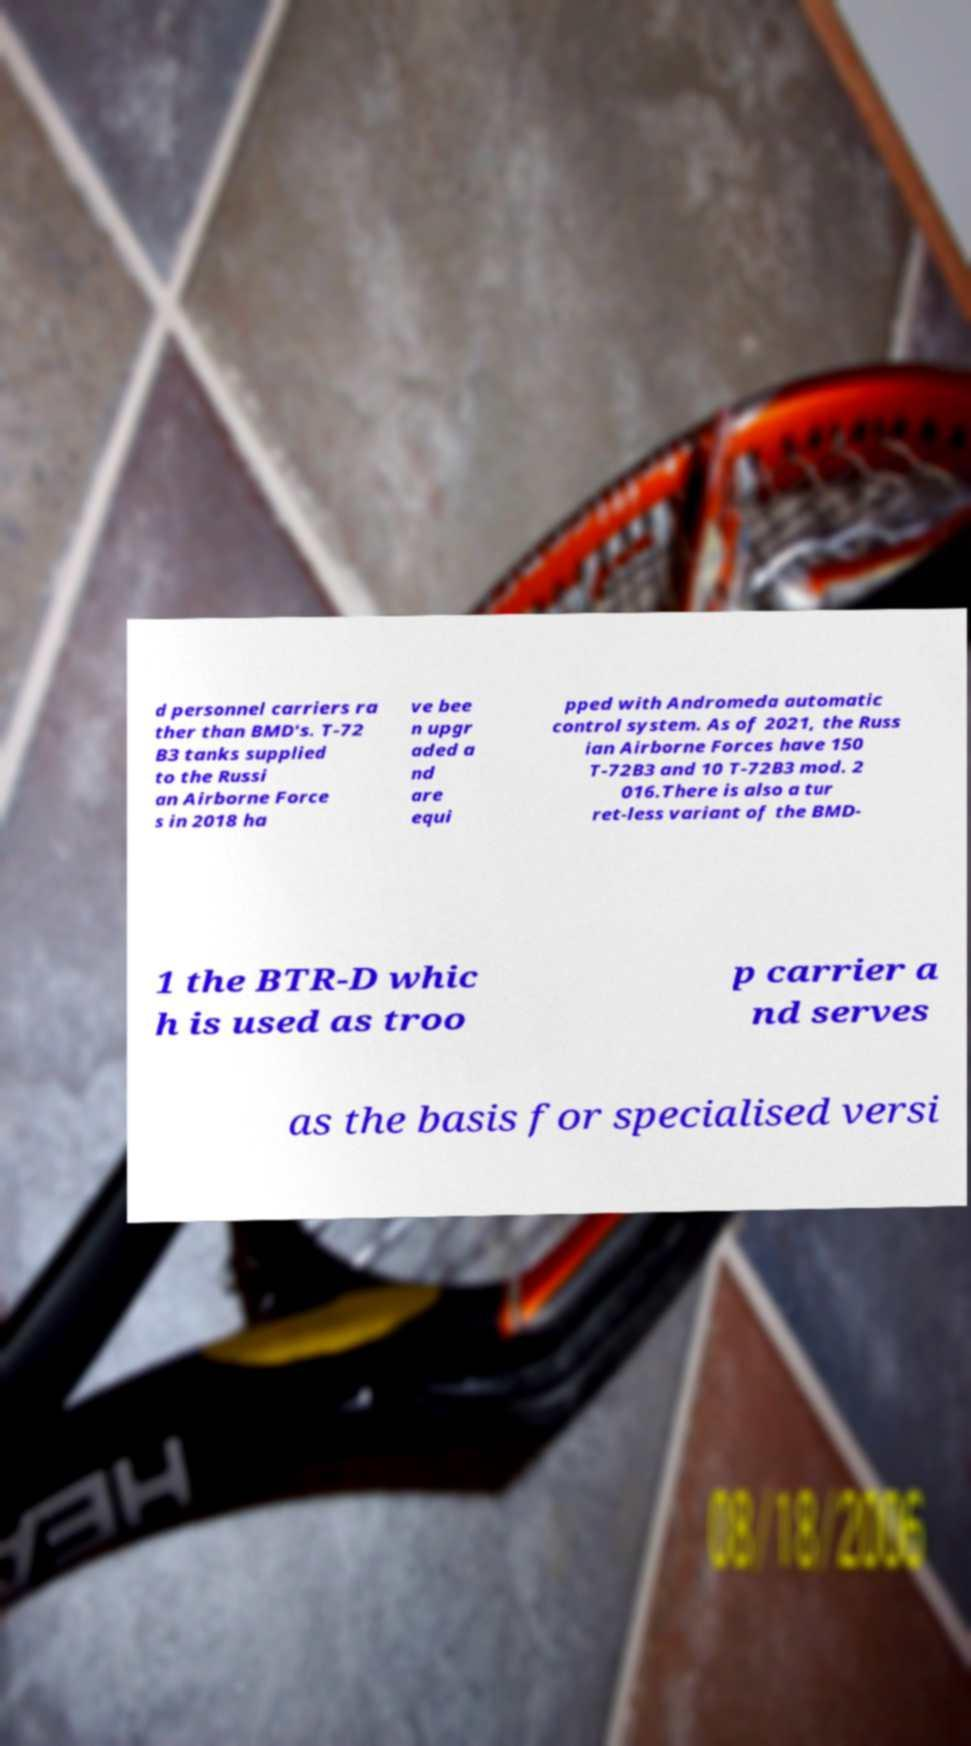Please identify and transcribe the text found in this image. d personnel carriers ra ther than BMD's. T-72 B3 tanks supplied to the Russi an Airborne Force s in 2018 ha ve bee n upgr aded a nd are equi pped with Andromeda automatic control system. As of 2021, the Russ ian Airborne Forces have 150 T-72B3 and 10 T-72B3 mod. 2 016.There is also a tur ret-less variant of the BMD- 1 the BTR-D whic h is used as troo p carrier a nd serves as the basis for specialised versi 